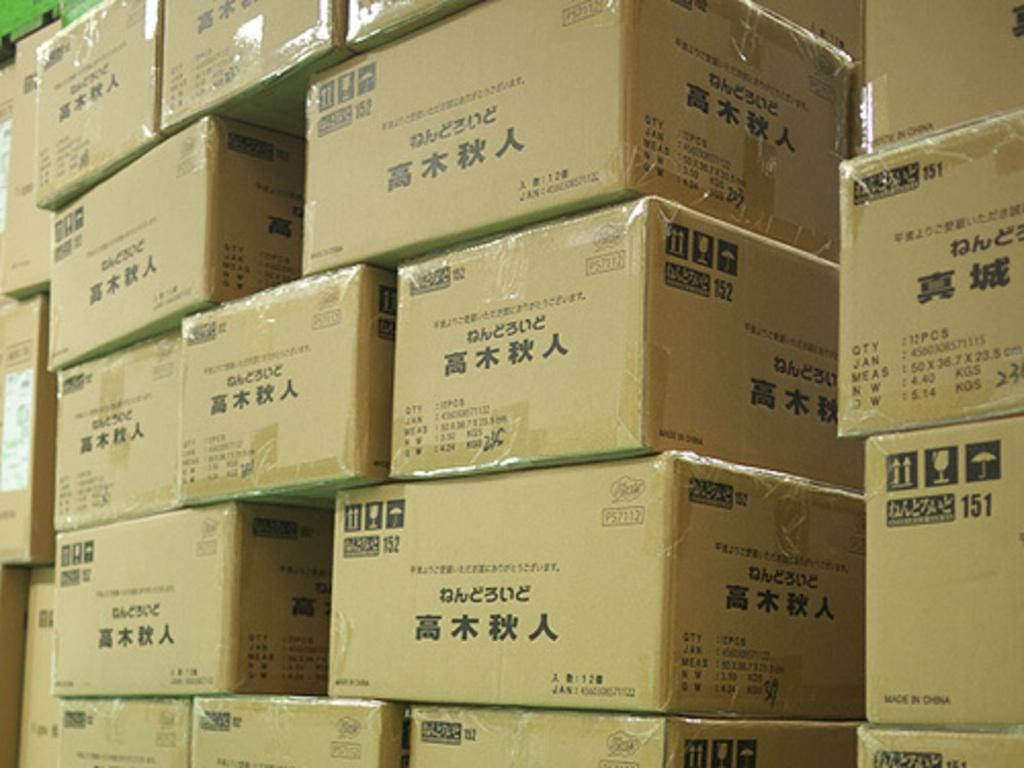What type of objects are present in the image? There are cartons and boxes in the image. Can you describe the appearance of these objects? The objects in the image are cartons and boxes. What type of frame is visible around the cartons and boxes in the image? There is no frame visible around the cartons and boxes in the image. What type of drug can be seen in the image? There is no drug present in the image; it features cartons and boxes. 